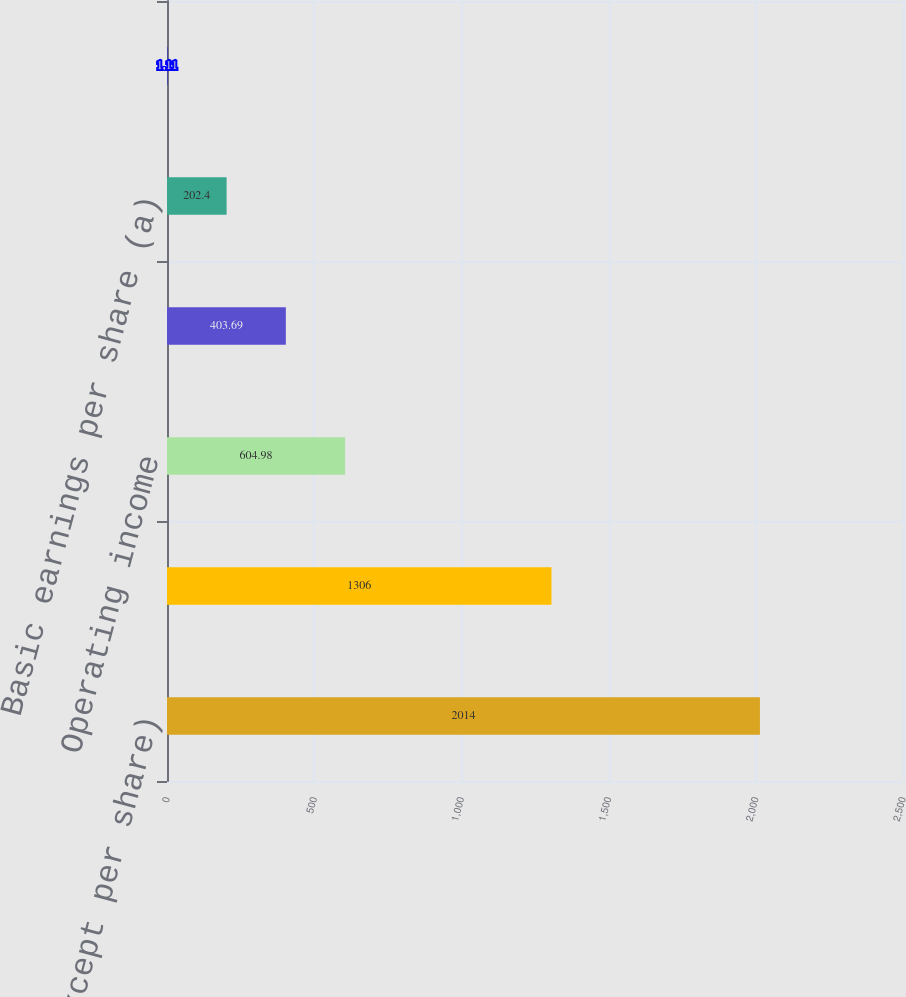Convert chart to OTSL. <chart><loc_0><loc_0><loc_500><loc_500><bar_chart><fcel>(in millions except per share)<fcel>Operating revenues<fcel>Operating income<fcel>Net income<fcel>Basic earnings per share (a)<fcel>Diluted earnings per share (a)<nl><fcel>2014<fcel>1306<fcel>604.98<fcel>403.69<fcel>202.4<fcel>1.11<nl></chart> 